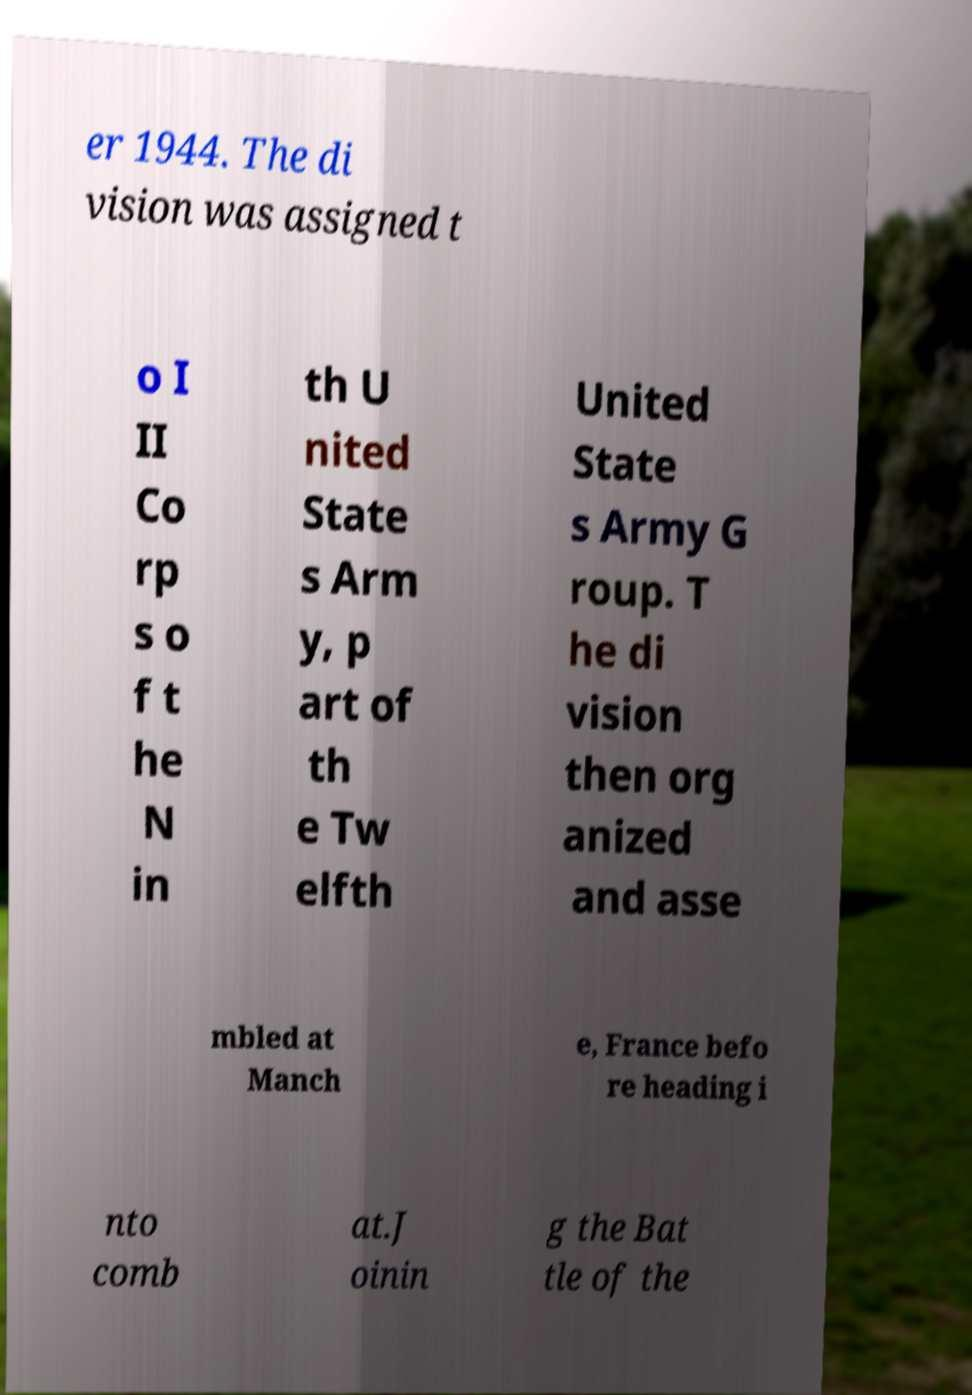Can you accurately transcribe the text from the provided image for me? er 1944. The di vision was assigned t o I II Co rp s o f t he N in th U nited State s Arm y, p art of th e Tw elfth United State s Army G roup. T he di vision then org anized and asse mbled at Manch e, France befo re heading i nto comb at.J oinin g the Bat tle of the 